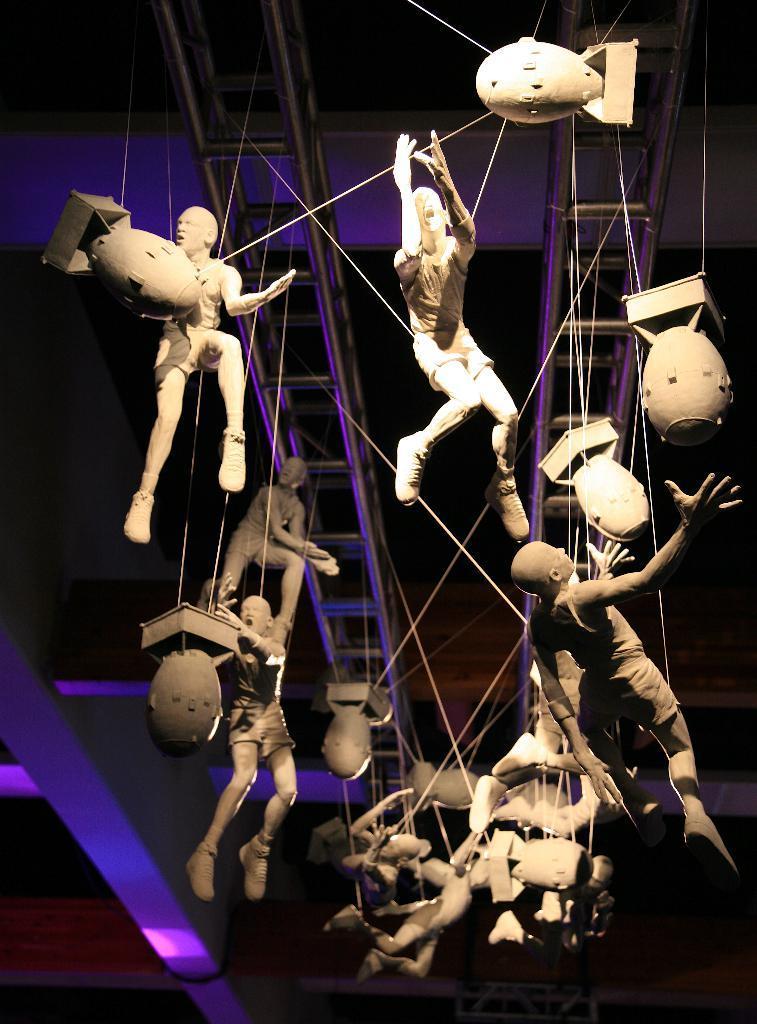In one or two sentences, can you explain what this image depicts? In this image we can see group of statues are tied with ropes on a metal frame inside a building. In the background we can see some lights. 